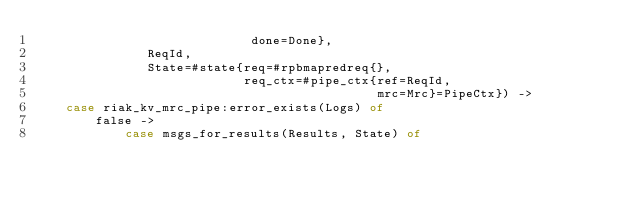Convert code to text. <code><loc_0><loc_0><loc_500><loc_500><_Erlang_>                             done=Done},
               ReqId,
               State=#state{req=#rpbmapredreq{},
                            req_ctx=#pipe_ctx{ref=ReqId,
                                              mrc=Mrc}=PipeCtx}) ->
    case riak_kv_mrc_pipe:error_exists(Logs) of
        false ->
            case msgs_for_results(Results, State) of</code> 